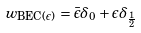<formula> <loc_0><loc_0><loc_500><loc_500>w _ { \text {BEC($\epsilon$)} } = \bar { \epsilon } \delta _ { 0 } + \epsilon \delta _ { \frac { 1 } { 2 } }</formula> 